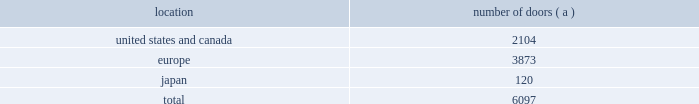Global brand concepts american living launched exclusively at jcpenney in february 2008 , american living is a new tradition in american style for family and home , developed for the jcpenney customer by polo ralph lauren 2019s global brand concepts .
American living features menswear , womenswear , childrenswear , accessories and home furnishings capturing the american spirit with modern style and superior quality .
A complete lifestyle brand for the entire family and the home , american living mixes sporty , iconic essentials with eye-catching looks for a free-spirited take on contemporary style for every day .
American living is available exclusively at jcpenney and jcp.com .
Chaps translates the classic heritage and timeless aesthetic of ralph lauren into an accessible line for men , women , children and the home .
From casual basics designed for versatility and ease of wear to smart , finely tailored silhouettes perfect for business and more formal occasions , chaps creates interchangeable classics that are both enduring and affordable .
The chaps men 2019s collection is available at select department and specialty stores .
The chaps collections for women , children and the home are available only at kohl 2019s and kohls.com .
Our wholesale segment our wholesale segment sells our products to leading upscale and certain mid-tier department stores , specialty stores and golf and pro shops , both domestically and internationally .
We have focused on elevating our brand and improving productivity by reducing the number of unproductive doors within department stores in which our products are sold , improving in-store product assortment and presentation , and improving full-price sell-throughs to consumers .
As of the end of fiscal 2009 , our ralph lauren-branded products were sold through approximately 6100 doors worldwide and during fiscal 2009 , we invested approximately $ 35 million in related shop-within-shops primarily in domestic and international department and specialty stores .
Department stores are our major wholesale customers in north america .
In europe , our wholesale sales are a varying mix of sales to both department stores and specialty shops , depending on the country .
Our collection brands 2014 women 2019s ralph lauren collection and black label and men 2019s purple label collection and black label 2014 are distributed through a limited number of premier fashion retailers .
In addition , we sell excess and out- of-season products through secondary distribution channels , including our retail factory stores .
In japan , our products are distributed primarily through shop-within-shops at premiere department stores .
The mix of business is weighted to polo ralph lauren in men 2019s and women 2019s blue label .
The distribution of men 2019s and women 2019s black label is also expanding through shop-within-shop presentations in top tier department stores across japan .
Worldwide distribution channels the table presents the approximate number of doors by geographic location , in which ralph lauren- branded products distributed by our wholesale segment were sold to consumers in our primary channels of distribution as of march 28 , 2009 : location number of doors ( a ) .
( a ) in asia/pacific ( excluding japan ) , our products are distributed by our licensing partners. .
What percentage of worldwide distribution channels doors were located in europe? 
Computations: (3873 / 6097)
Answer: 0.63523. Global brand concepts american living launched exclusively at jcpenney in february 2008 , american living is a new tradition in american style for family and home , developed for the jcpenney customer by polo ralph lauren 2019s global brand concepts .
American living features menswear , womenswear , childrenswear , accessories and home furnishings capturing the american spirit with modern style and superior quality .
A complete lifestyle brand for the entire family and the home , american living mixes sporty , iconic essentials with eye-catching looks for a free-spirited take on contemporary style for every day .
American living is available exclusively at jcpenney and jcp.com .
Chaps translates the classic heritage and timeless aesthetic of ralph lauren into an accessible line for men , women , children and the home .
From casual basics designed for versatility and ease of wear to smart , finely tailored silhouettes perfect for business and more formal occasions , chaps creates interchangeable classics that are both enduring and affordable .
The chaps men 2019s collection is available at select department and specialty stores .
The chaps collections for women , children and the home are available only at kohl 2019s and kohls.com .
Our wholesale segment our wholesale segment sells our products to leading upscale and certain mid-tier department stores , specialty stores and golf and pro shops , both domestically and internationally .
We have focused on elevating our brand and improving productivity by reducing the number of unproductive doors within department stores in which our products are sold , improving in-store product assortment and presentation , and improving full-price sell-throughs to consumers .
As of the end of fiscal 2009 , our ralph lauren-branded products were sold through approximately 6100 doors worldwide and during fiscal 2009 , we invested approximately $ 35 million in related shop-within-shops primarily in domestic and international department and specialty stores .
Department stores are our major wholesale customers in north america .
In europe , our wholesale sales are a varying mix of sales to both department stores and specialty shops , depending on the country .
Our collection brands 2014 women 2019s ralph lauren collection and black label and men 2019s purple label collection and black label 2014 are distributed through a limited number of premier fashion retailers .
In addition , we sell excess and out- of-season products through secondary distribution channels , including our retail factory stores .
In japan , our products are distributed primarily through shop-within-shops at premiere department stores .
The mix of business is weighted to polo ralph lauren in men 2019s and women 2019s blue label .
The distribution of men 2019s and women 2019s black label is also expanding through shop-within-shop presentations in top tier department stores across japan .
Worldwide distribution channels the table presents the approximate number of doors by geographic location , in which ralph lauren- branded products distributed by our wholesale segment were sold to consumers in our primary channels of distribution as of march 28 , 2009 : location number of doors ( a ) .
( a ) in asia/pacific ( excluding japan ) , our products are distributed by our licensing partners. .
What percentage of worldwide distribution channels doors were located in japan? 
Computations: (120 / 6097)
Answer: 0.01968. 